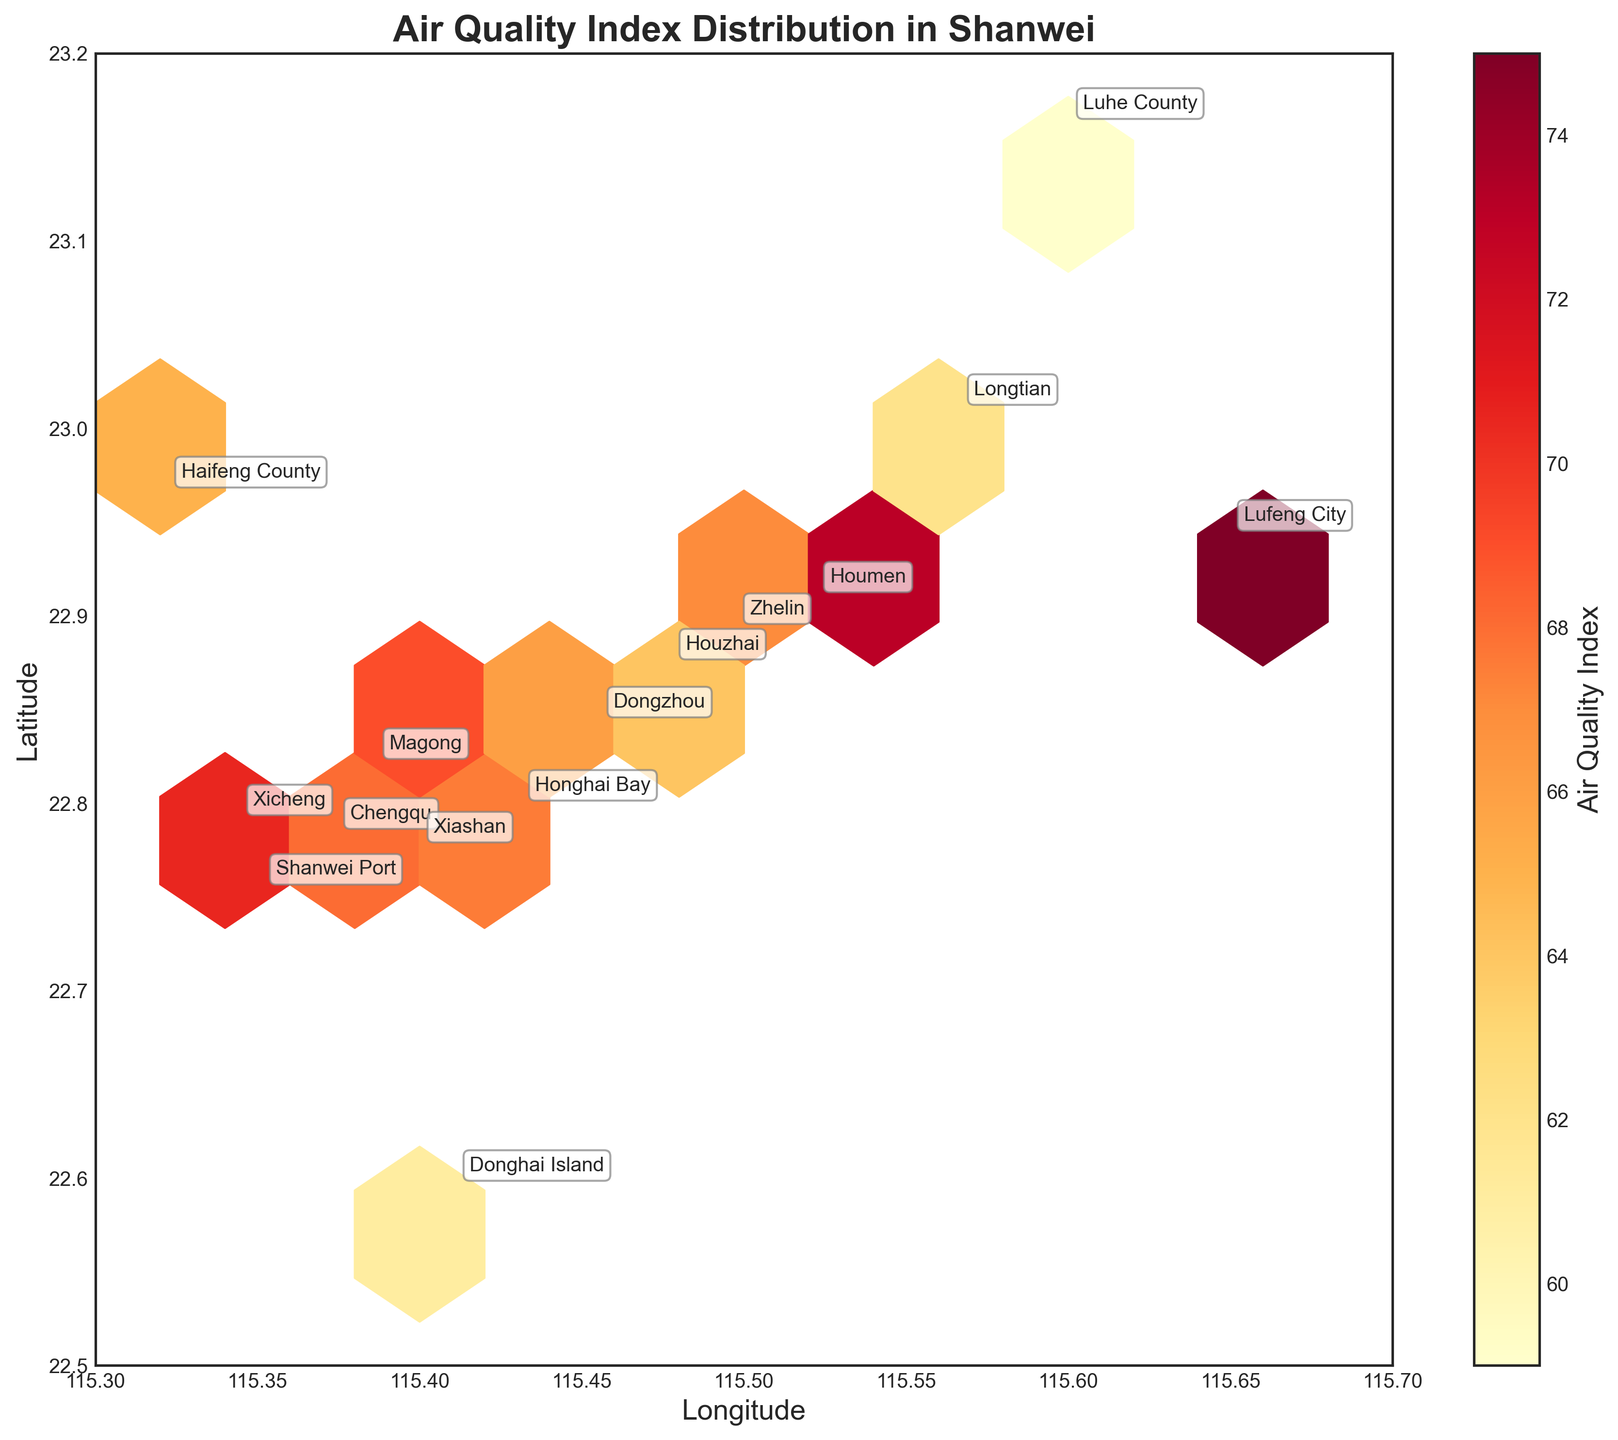What is the title of the plot? The title of the plot is usually placed at the top of the figure. Here, it is labeled as 'Air Quality Index Distribution in Shanwei'.
Answer: Air Quality Index Distribution in Shanwei What does the color of the hexagons represent? In a hexbin plot, the color typically represents the intensity or value of the third variable being visualized. According to the plot, the color indicates the Air Quality Index (AQI) values.
Answer: Air Quality Index (AQI) Which district has the highest Air Quality Index (AQI)? The district with the highest AQI can be identified by locating the point on the plot with the label having the darkest shade within the hexagon. 'Lufeng City' has an AQI of 75, the highest in the chart.
Answer: Lufeng City What are the ranges for the latitude and longitude axes? The ranges for the axes can be seen from the labels on the side of the plot. The latitude ranges from 22.5 to 23.2 and the longitude ranges from 115.3 to 115.7.
Answer: Latitude: 22.5 to 23.2, Longitude: 115.3 to 115.7 Which districts fall within the hexagon with the brightest color? The hexagons with the brightest color represent lower AQI values. The districts 'Luhe County' and 'Longtian' have relatively lower AQI values (59 and 62). This is indicated by their location in the lighter hexagons.
Answer: Luhe County, Longtian Is there a general trend observed in AQI values from north to south? By visually inspecting the plot, you can see that lower AQI values (lighter color) are generally located towards the north while higher AQI values (darker color) are distributed in the south. This suggests a gradient where northern areas tend to have better air quality.
Answer: AQI decreases from north to south Which has a higher AQI: Honghai Bay or Chengqu? By looking at the annotated data points on the hexbin plot, you can see that Honghai Bay has an AQI of 72 while Chengqu has an AQI of 68.
Answer: Honghai Bay How many districts have AQI values above 70? By checking the annotated AQI values, there are four districts with AQI values above 70: Honghai Bay (72), Lufeng City (75), Shanwei Port (70), and Houmen (73).
Answer: Four districts What's the average AQI across all districts? To calculate the average AQI, sum all the AQI values and divide by the number of districts. The sum of AQI values is (68 + 72 + 65 + 59 + 75 + 70 + 63 + 67 + 61 + 69 + 73 + 66 + 71 + 64 + 62) = 935. There are 15 districts. So, the average is 935 / 15 = 62.33.
Answer: 62.33 